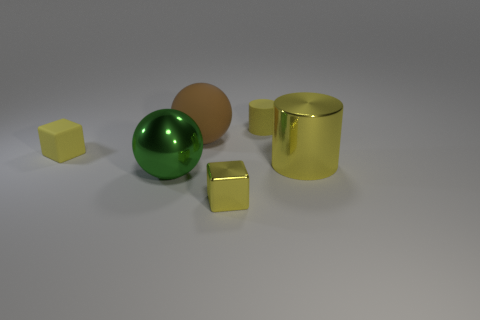What is the size of the shiny block that is the same color as the small cylinder?
Provide a succinct answer. Small. What shape is the big thing in front of the big object right of the tiny yellow matte cylinder?
Provide a short and direct response. Sphere. Do the big green metal object and the brown rubber thing behind the yellow rubber block have the same shape?
Provide a succinct answer. Yes. The matte cube that is the same size as the yellow rubber cylinder is what color?
Offer a very short reply. Yellow. Are there fewer objects that are on the right side of the metal cylinder than yellow cubes that are on the left side of the small yellow metallic object?
Make the answer very short. Yes. What is the shape of the tiny yellow object in front of the cube left of the shiny thing in front of the large green metallic thing?
Provide a succinct answer. Cube. There is a small rubber thing that is on the right side of the shiny cube; does it have the same color as the cylinder that is in front of the small yellow rubber block?
Keep it short and to the point. Yes. There is a large metallic object that is the same color as the matte cylinder; what shape is it?
Provide a succinct answer. Cylinder. How many shiny things are either yellow cubes or big yellow things?
Your answer should be compact. 2. There is a cylinder behind the tiny matte cube left of the small cube that is on the right side of the small yellow matte cube; what color is it?
Offer a very short reply. Yellow. 